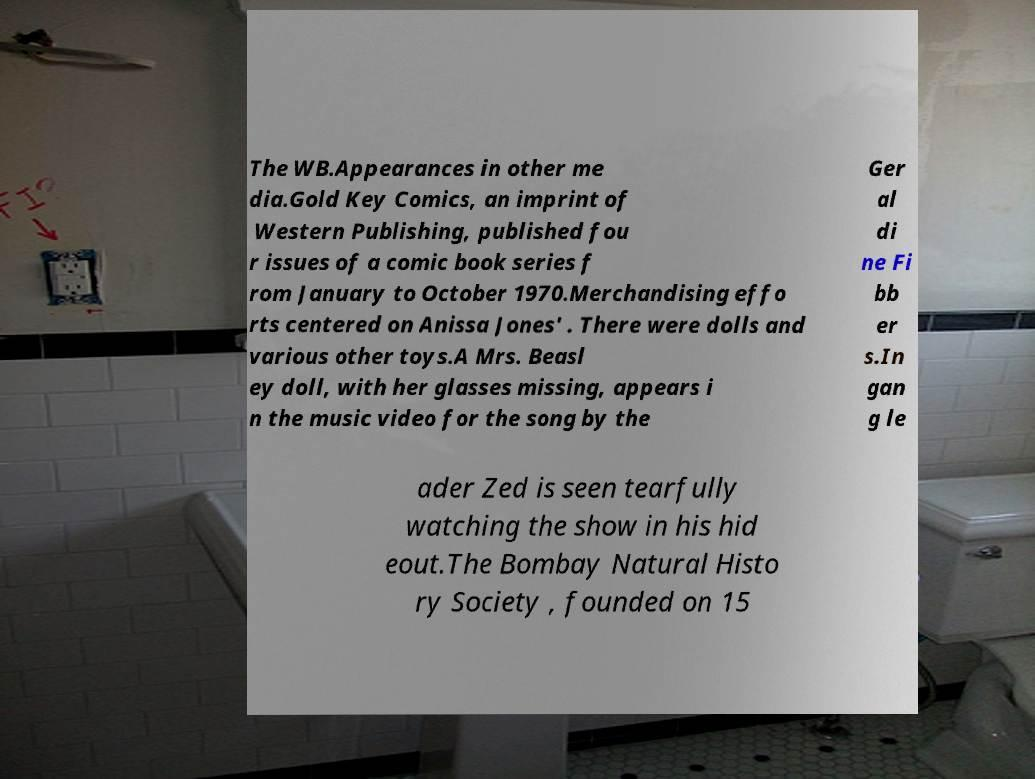Could you assist in decoding the text presented in this image and type it out clearly? The WB.Appearances in other me dia.Gold Key Comics, an imprint of Western Publishing, published fou r issues of a comic book series f rom January to October 1970.Merchandising effo rts centered on Anissa Jones' . There were dolls and various other toys.A Mrs. Beasl ey doll, with her glasses missing, appears i n the music video for the song by the Ger al di ne Fi bb er s.In gan g le ader Zed is seen tearfully watching the show in his hid eout.The Bombay Natural Histo ry Society , founded on 15 